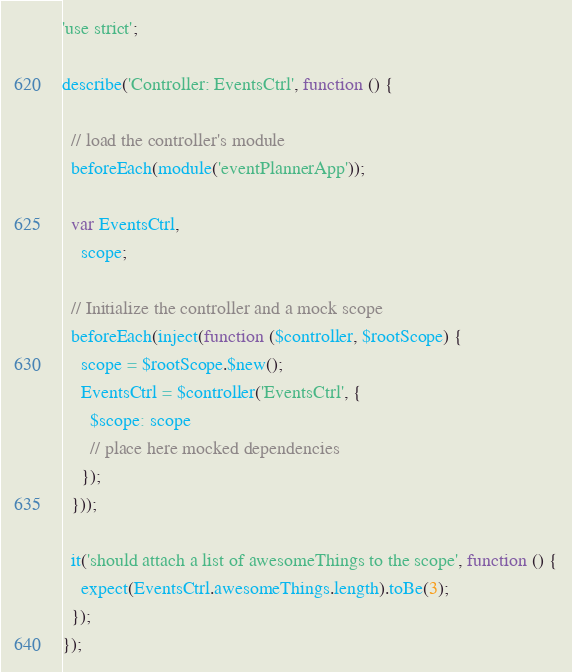Convert code to text. <code><loc_0><loc_0><loc_500><loc_500><_JavaScript_>'use strict';

describe('Controller: EventsCtrl', function () {

  // load the controller's module
  beforeEach(module('eventPlannerApp'));

  var EventsCtrl,
    scope;

  // Initialize the controller and a mock scope
  beforeEach(inject(function ($controller, $rootScope) {
    scope = $rootScope.$new();
    EventsCtrl = $controller('EventsCtrl', {
      $scope: scope
      // place here mocked dependencies
    });
  }));

  it('should attach a list of awesomeThings to the scope', function () {
    expect(EventsCtrl.awesomeThings.length).toBe(3);
  });
});
</code> 